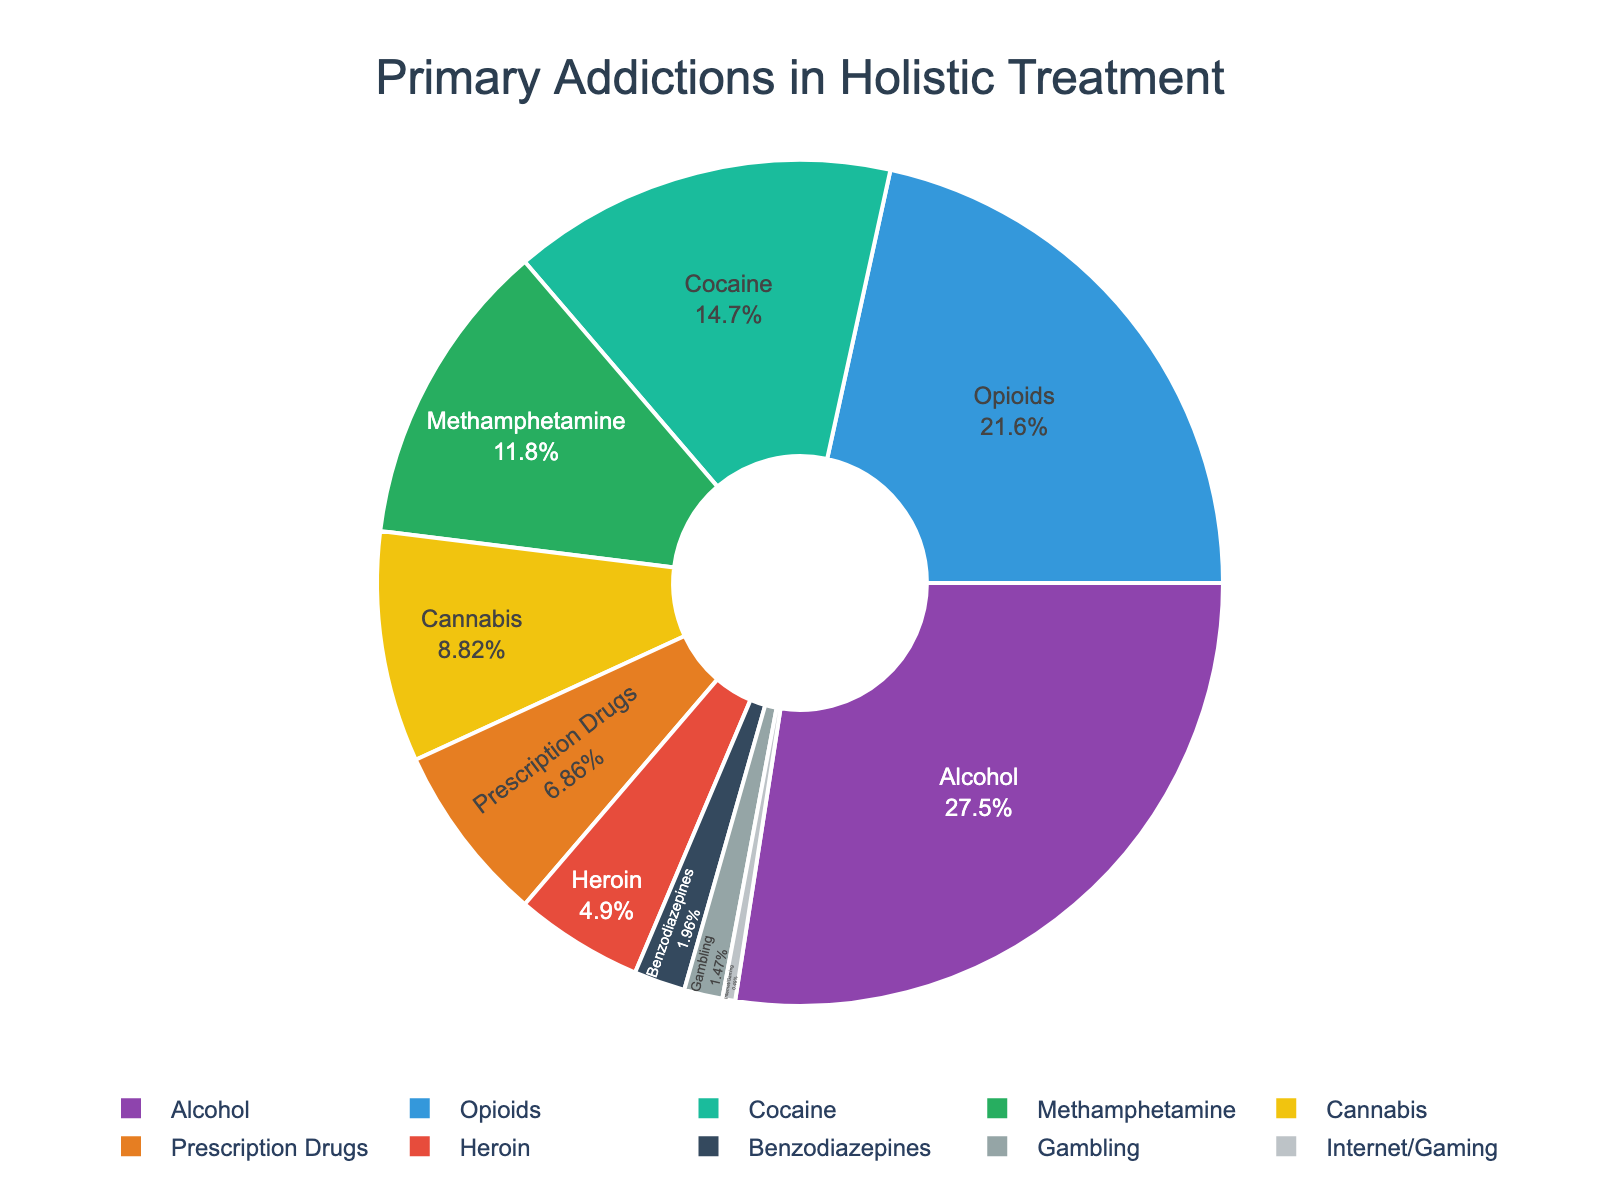what is the primary addiction with the highest percentage? Alcohol has the highest percentage at 28%. The figure displays this category as the largest segment in the pie chart.
Answer: Alcohol Which addiction has a higher percentage: Opioids or Methamphetamine? By comparing the sizes of the sections in the pie chart, Opioids have 22% while Methamphetamine has 12%. Therefore, Opioids have a higher percentage.
Answer: Opioids What is the combined percentage of patients seeking holistic treatment for Alcohol and Cocaine addiction? Add the percentages of Alcohol (28%) and Cocaine (15%) to find the combined percentage: 28 + 15 = 43%.
Answer: 43% How many more patients seek treatment for Cannabis addiction compared to internet/gaming addiction? Subtract the percentage for Internet/Gaming (0.5%) from the percentage for Cannabis (9%): 9 - 0.5 = 8.5%.
Answer: 8.5% Compare the sizes of the segments for Prescription Drugs and Heroin. Which is greater, and by how much? Prescription Drugs account for 7%, and Heroin accounts for 5%. The difference is 7 - 5 = 2%.
Answer: Prescription Drugs, by 2% Which addiction has the smallest percentage representation? The smallest section in the pie chart represents Internet/Gaming at 0.5%.
Answer: Internet/Gaming What is the combined percentage of patients seeking treatment for non-substance addictions (Gambling and Internet/Gaming)? Add the percentages for Gambling (1.5%) and Internet/Gaming (0.5%): 1.5 + 0.5 = 2%.
Answer: 2% Is the percentage for Opioids greater than the combined percentage for Cannabis and Prescription Drugs? Calculate the combined percentage for Cannabis (9%) and Prescription Drugs (7%): 9 + 7 = 16%. The percentage for Opioids is 22%, which is greater.
Answer: Yes Which substances have a smaller percentage than Cocaine addiction? The substances with percentages smaller than Cocaine (15%) are Methamphetamine (12%), Cannabis (9%), Prescription Drugs (7%), Heroin (5%), Benzodiazepines (2%), Gambling (1.5%), and Internet/Gaming (0.5%).
Answer: Methamphetamine, Cannabis, Prescription Drugs, Heroin, Benzodiazepines, Gambling, Internet/Gaming What percentage of patients seek treatment for either Alcohol or Benzodiazepines addiction? Add the percentages for Alcohol (28%) and Benzodiazepines (2%): 28 + 2 = 30%.
Answer: 30% 